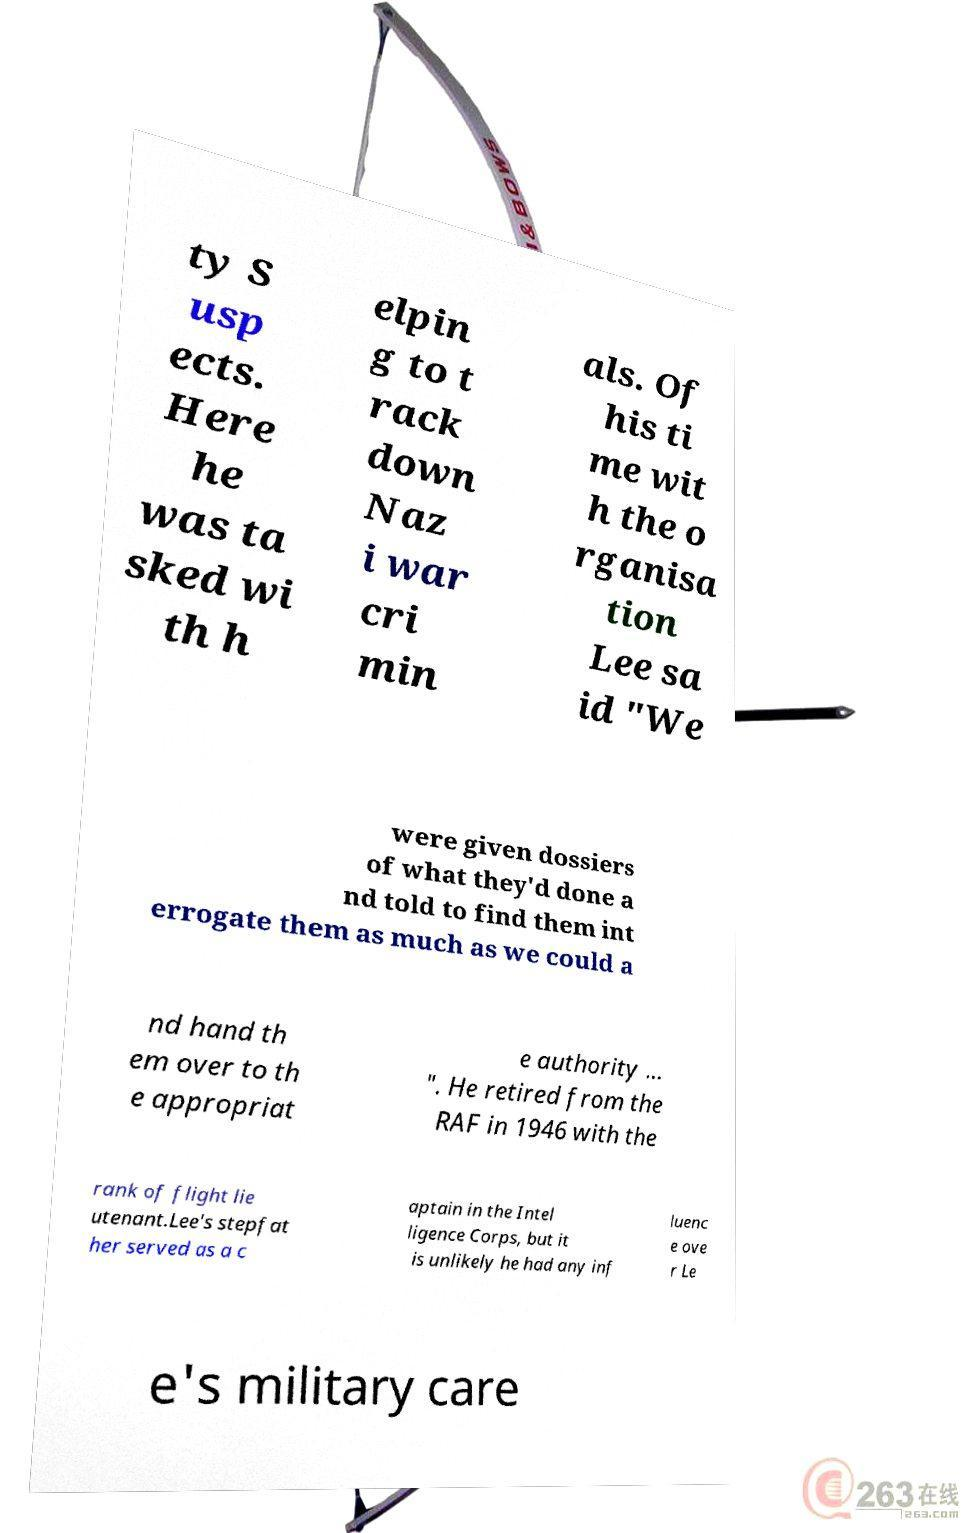Could you extract and type out the text from this image? ty S usp ects. Here he was ta sked wi th h elpin g to t rack down Naz i war cri min als. Of his ti me wit h the o rganisa tion Lee sa id "We were given dossiers of what they'd done a nd told to find them int errogate them as much as we could a nd hand th em over to th e appropriat e authority ... ". He retired from the RAF in 1946 with the rank of flight lie utenant.Lee's stepfat her served as a c aptain in the Intel ligence Corps, but it is unlikely he had any inf luenc e ove r Le e's military care 